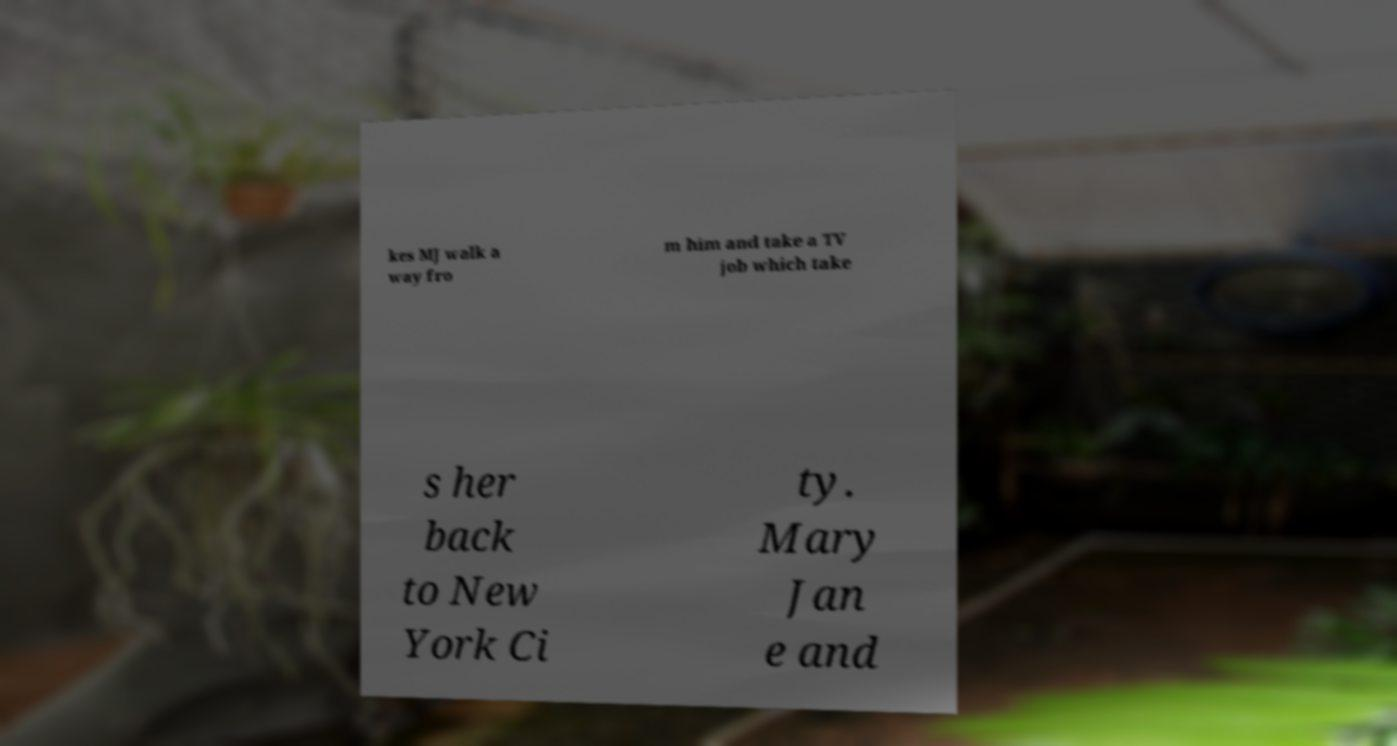What messages or text are displayed in this image? I need them in a readable, typed format. kes MJ walk a way fro m him and take a TV job which take s her back to New York Ci ty. Mary Jan e and 